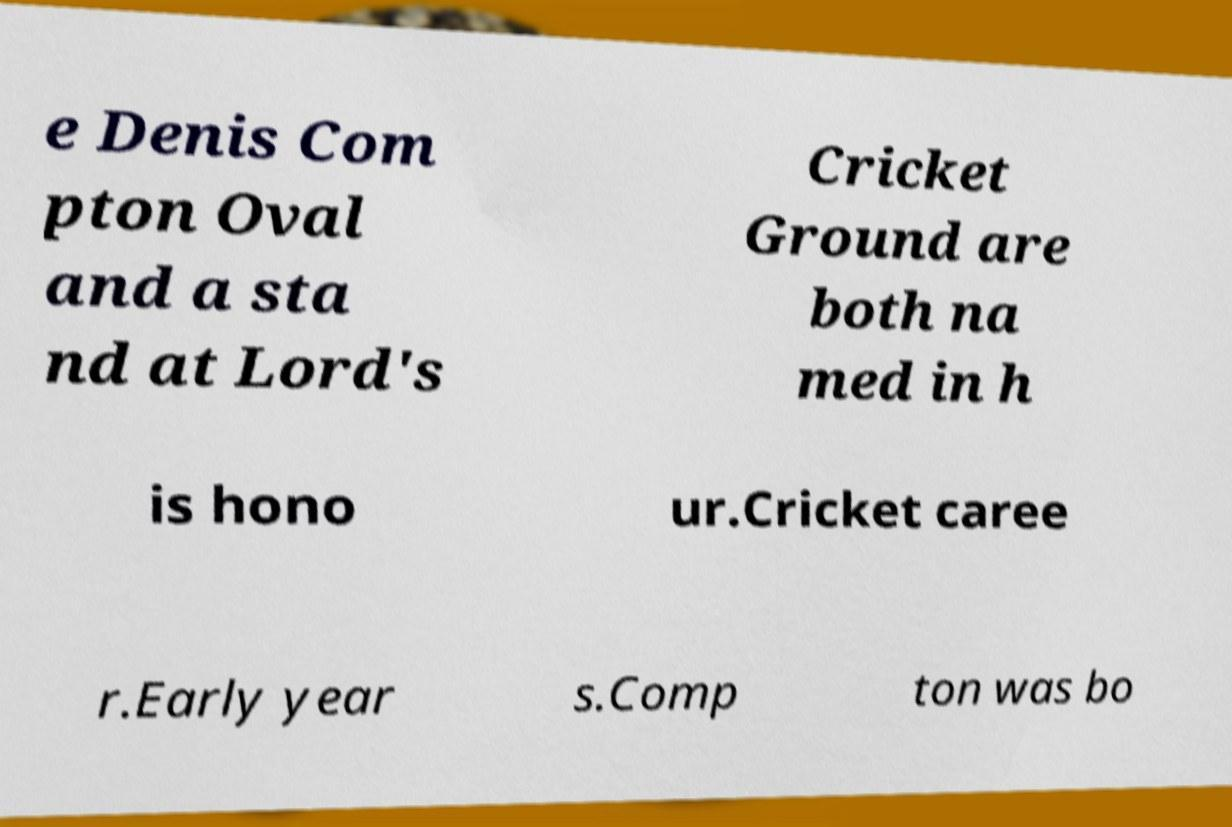Could you assist in decoding the text presented in this image and type it out clearly? e Denis Com pton Oval and a sta nd at Lord's Cricket Ground are both na med in h is hono ur.Cricket caree r.Early year s.Comp ton was bo 